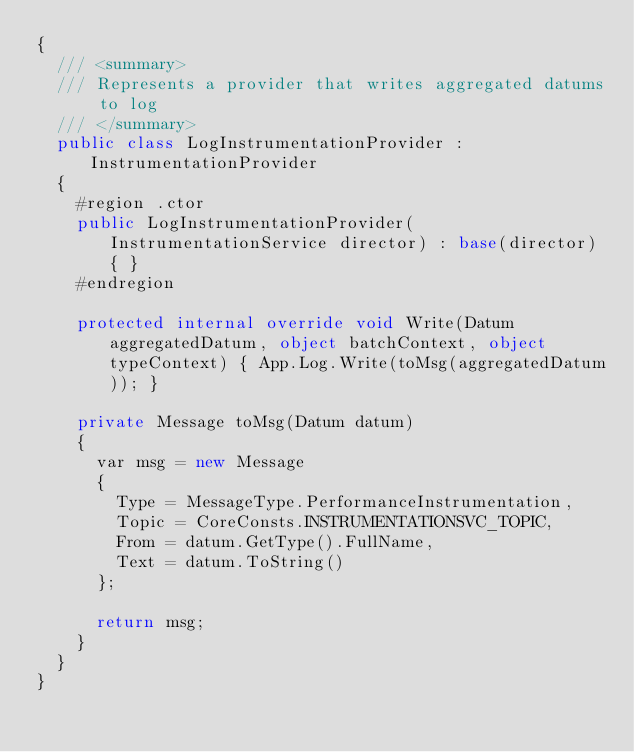<code> <loc_0><loc_0><loc_500><loc_500><_C#_>{
  /// <summary>
  /// Represents a provider that writes aggregated datums to log
  /// </summary>
  public class LogInstrumentationProvider : InstrumentationProvider
  {
    #region .ctor
    public LogInstrumentationProvider(InstrumentationService director) : base(director) { }
    #endregion

    protected internal override void Write(Datum aggregatedDatum, object batchContext, object typeContext) { App.Log.Write(toMsg(aggregatedDatum)); }

    private Message toMsg(Datum datum)
    {
      var msg = new Message
      {
        Type = MessageType.PerformanceInstrumentation,
        Topic = CoreConsts.INSTRUMENTATIONSVC_TOPIC,
        From = datum.GetType().FullName,
        Text = datum.ToString()
      };

      return msg;
    }
  }
}</code> 